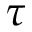<formula> <loc_0><loc_0><loc_500><loc_500>\tau</formula> 